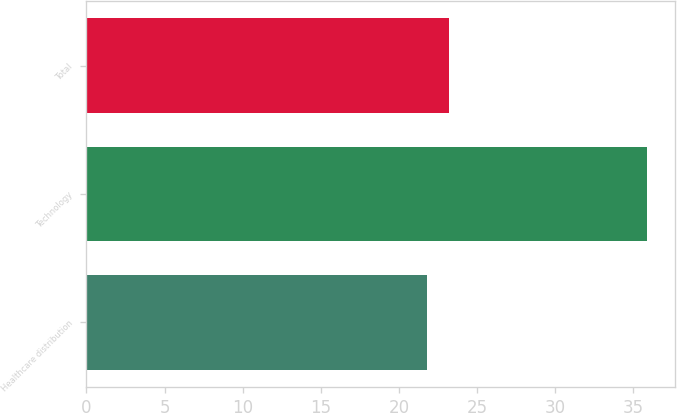<chart> <loc_0><loc_0><loc_500><loc_500><bar_chart><fcel>Healthcare distribution<fcel>Technology<fcel>Total<nl><fcel>21.8<fcel>35.9<fcel>23.21<nl></chart> 